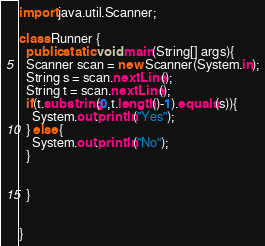<code> <loc_0><loc_0><loc_500><loc_500><_Java_>import java.util.Scanner;

class Runner {
  public static void main(String[] args){
  Scanner scan = new Scanner(System.in);
  String s = scan.nextLine();
  String t = scan.nextLine();
  if(t.substring(0,t.length()-1).equals(s)){
    System.out.println("Yes");
  } else {
    System.out.println("No");
  }
  
  
  }


}</code> 